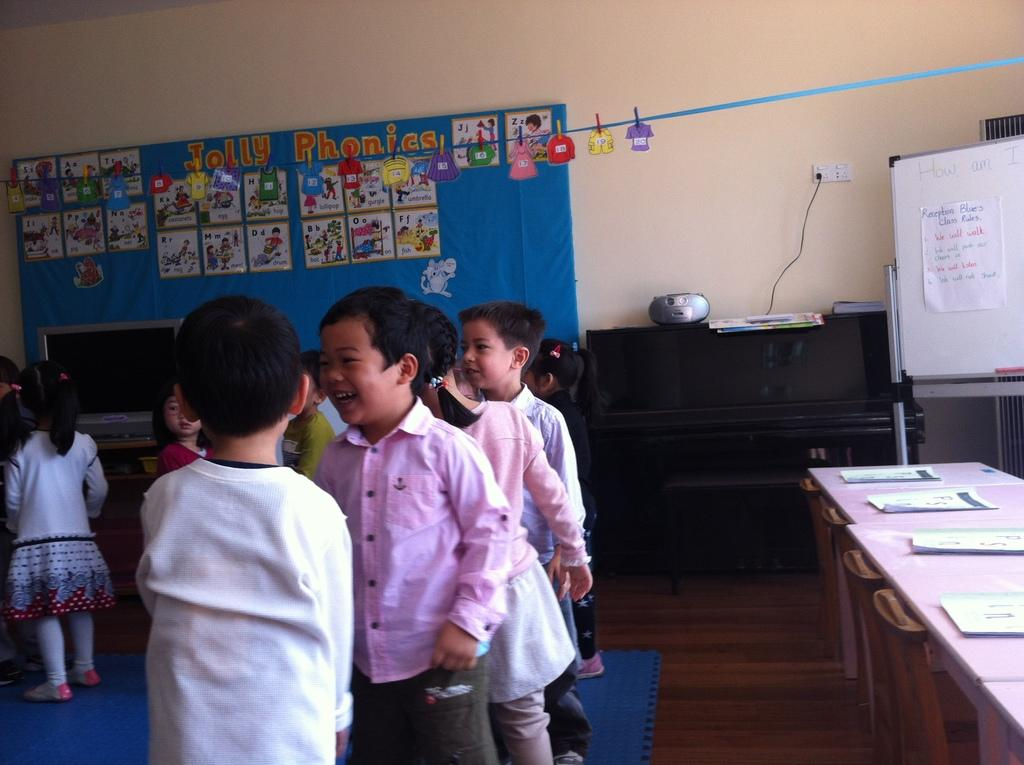What is the main subject of the image? The main subject of the image is a group of children. Where are the children located in the image? The children are on the floor in the image. What can be seen in the background of the image? There is a wall in the image. What electronic device is present in the image? There is a monitor in the image. What else can be seen in the image besides the children and the monitor? There are boards and additional objects present in the image. What type of waves can be seen crashing on the shore in the image? There are no waves or shore present in the image; it features a group of children, boards, a wall, and a monitor. How many teeth can be seen in the image? There are no teeth visible in the image. 